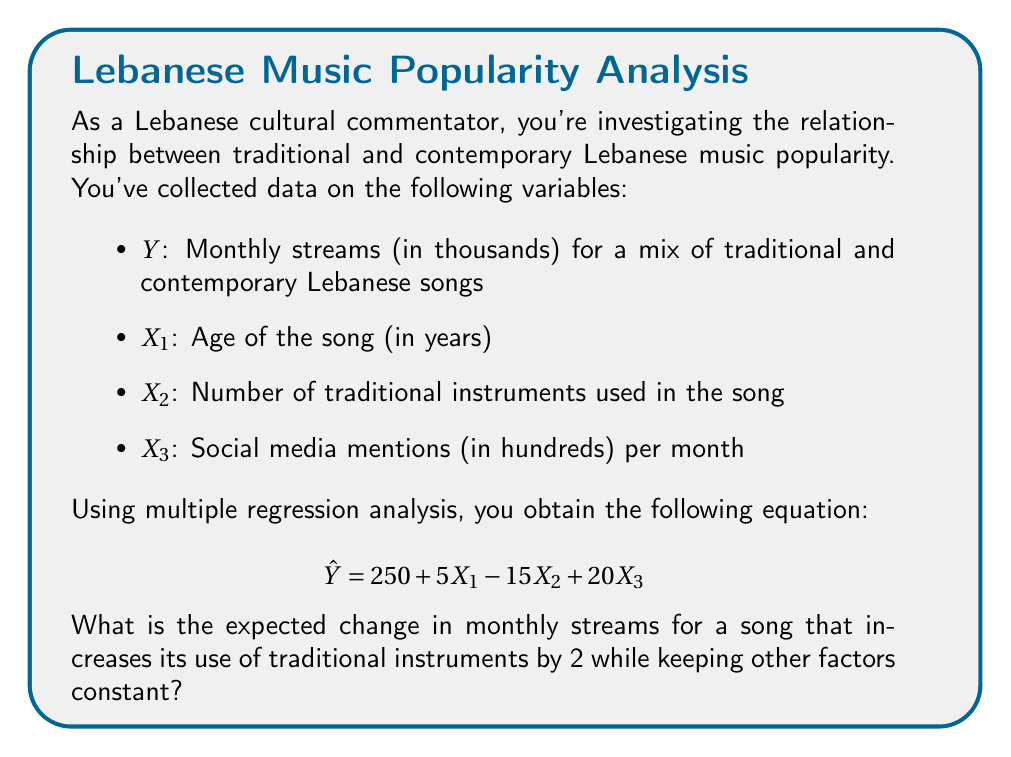Provide a solution to this math problem. To solve this problem, we need to focus on the coefficient of X₂ in the regression equation, as it represents the number of traditional instruments used in the song.

Step 1: Identify the coefficient for X₂
From the given equation: $$ \hat{Y} = 250 + 5X_1 - 15X_2 + 20X_3 $$
The coefficient for X₂ is -15.

Step 2: Interpret the coefficient
The coefficient -15 means that for each unit increase in X₂ (number of traditional instruments), we expect a decrease of 15,000 monthly streams, assuming all other variables remain constant.

Step 3: Calculate the change for an increase of 2 traditional instruments
Change in monthly streams = Coefficient × Change in X₂
Change in monthly streams = -15 × 2 = -30

Step 4: Interpret the result
An increase of 2 traditional instruments is expected to result in a decrease of 30,000 monthly streams, assuming all other factors remain constant.
Answer: -30,000 streams 